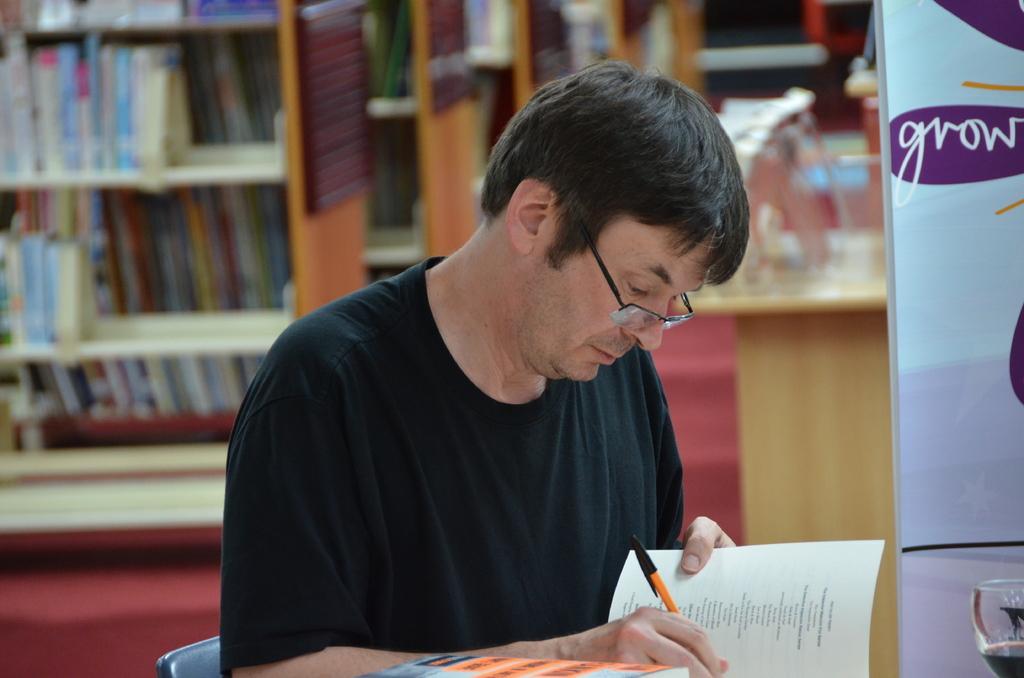Could you give a brief overview of what you see in this image? In this image I can see a person sitting on the chair and holding the pen and book. Back I can see few book racks, banners and background is blurred. 